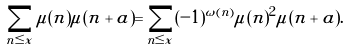Convert formula to latex. <formula><loc_0><loc_0><loc_500><loc_500>\sum _ { n \leq x } \mu ( n ) \mu ( n + a ) = \sum _ { n \leq x } ( - 1 ) ^ { \omega ( n ) } \mu ( n ) ^ { 2 } \mu ( n + a ) .</formula> 